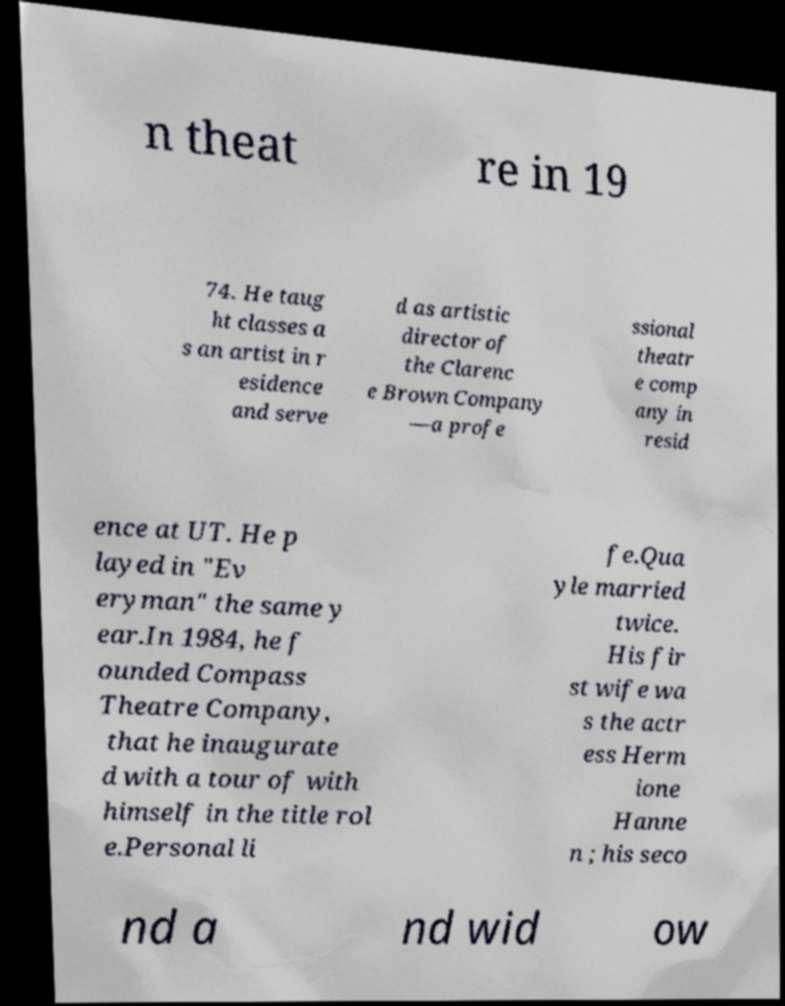What messages or text are displayed in this image? I need them in a readable, typed format. n theat re in 19 74. He taug ht classes a s an artist in r esidence and serve d as artistic director of the Clarenc e Brown Company —a profe ssional theatr e comp any in resid ence at UT. He p layed in "Ev eryman" the same y ear.In 1984, he f ounded Compass Theatre Company, that he inaugurate d with a tour of with himself in the title rol e.Personal li fe.Qua yle married twice. His fir st wife wa s the actr ess Herm ione Hanne n ; his seco nd a nd wid ow 